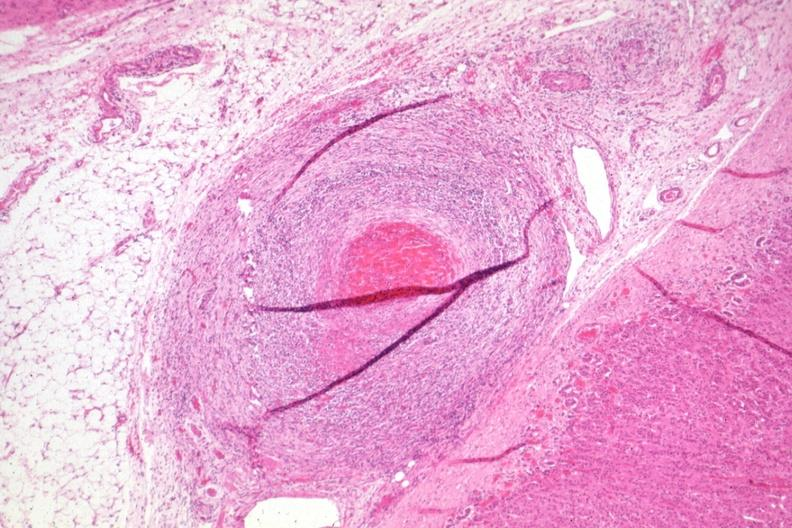what is present?
Answer the question using a single word or phrase. Endocrine 